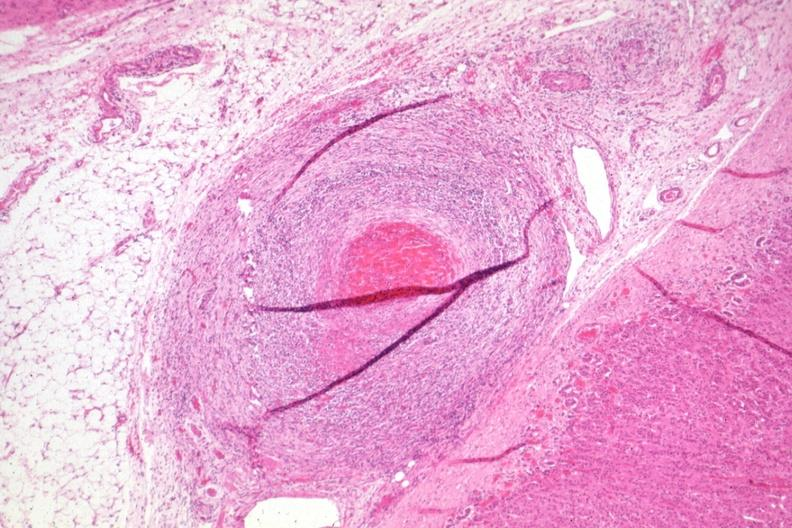what is present?
Answer the question using a single word or phrase. Endocrine 